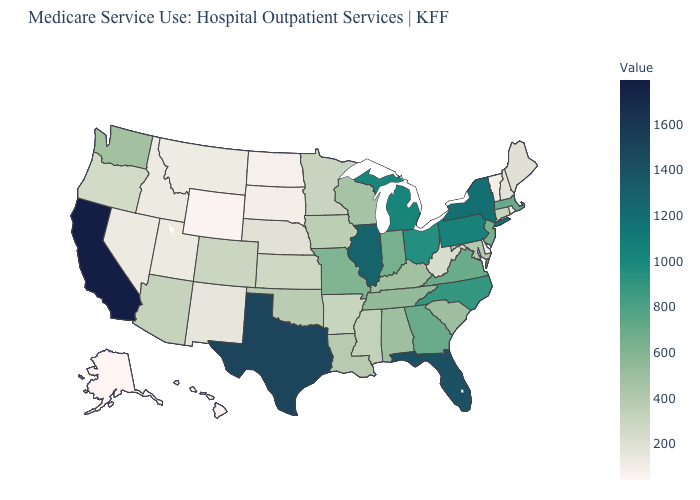Among the states that border Montana , does South Dakota have the highest value?
Quick response, please. No. Which states hav the highest value in the MidWest?
Keep it brief. Illinois. Which states have the highest value in the USA?
Be succinct. California. Among the states that border West Virginia , which have the highest value?
Concise answer only. Pennsylvania. Does the map have missing data?
Quick response, please. No. Does Alaska have the lowest value in the USA?
Write a very short answer. Yes. Among the states that border Massachusetts , which have the lowest value?
Be succinct. Rhode Island. 